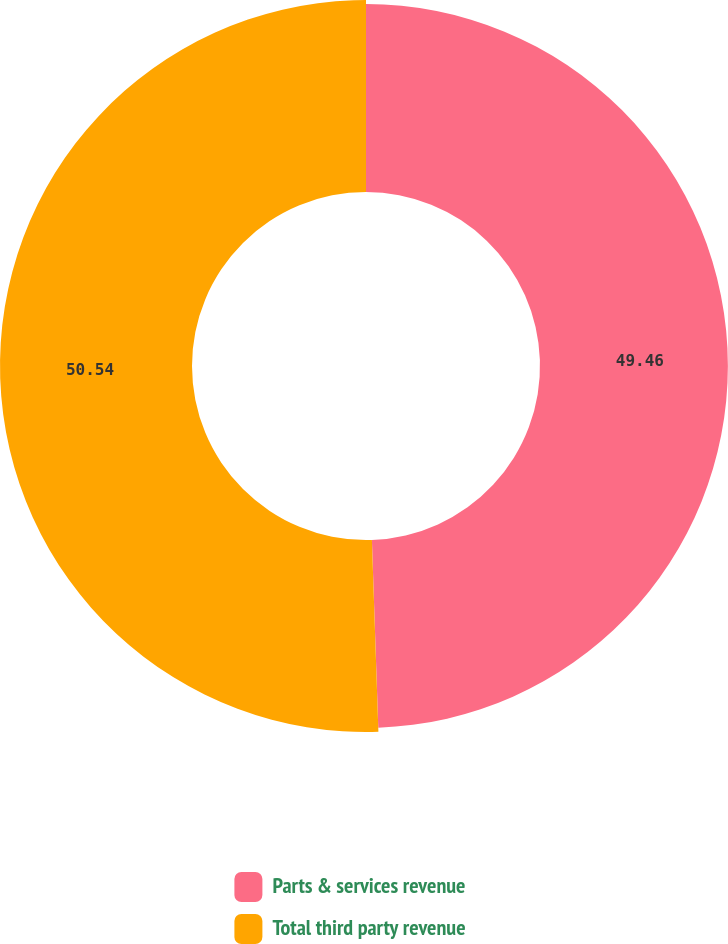Convert chart to OTSL. <chart><loc_0><loc_0><loc_500><loc_500><pie_chart><fcel>Parts & services revenue<fcel>Total third party revenue<nl><fcel>49.46%<fcel>50.54%<nl></chart> 